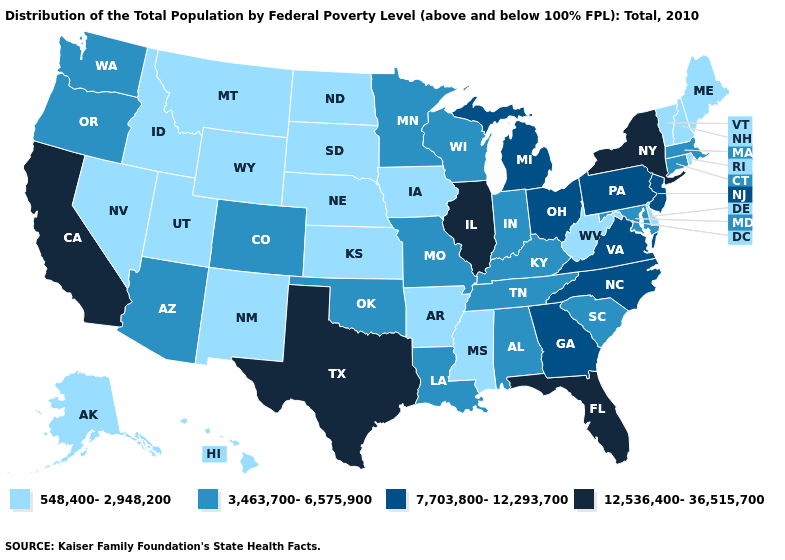What is the value of Wyoming?
Quick response, please. 548,400-2,948,200. Does Arizona have the highest value in the West?
Write a very short answer. No. Name the states that have a value in the range 12,536,400-36,515,700?
Concise answer only. California, Florida, Illinois, New York, Texas. What is the value of Virginia?
Be succinct. 7,703,800-12,293,700. Which states have the lowest value in the USA?
Concise answer only. Alaska, Arkansas, Delaware, Hawaii, Idaho, Iowa, Kansas, Maine, Mississippi, Montana, Nebraska, Nevada, New Hampshire, New Mexico, North Dakota, Rhode Island, South Dakota, Utah, Vermont, West Virginia, Wyoming. Which states have the lowest value in the MidWest?
Answer briefly. Iowa, Kansas, Nebraska, North Dakota, South Dakota. Does New Hampshire have the lowest value in the USA?
Answer briefly. Yes. Does Florida have the highest value in the USA?
Keep it brief. Yes. Which states have the lowest value in the MidWest?
Keep it brief. Iowa, Kansas, Nebraska, North Dakota, South Dakota. How many symbols are there in the legend?
Answer briefly. 4. What is the value of West Virginia?
Keep it brief. 548,400-2,948,200. Does Connecticut have the lowest value in the Northeast?
Be succinct. No. What is the value of Delaware?
Give a very brief answer. 548,400-2,948,200. Does the map have missing data?
Keep it brief. No. 